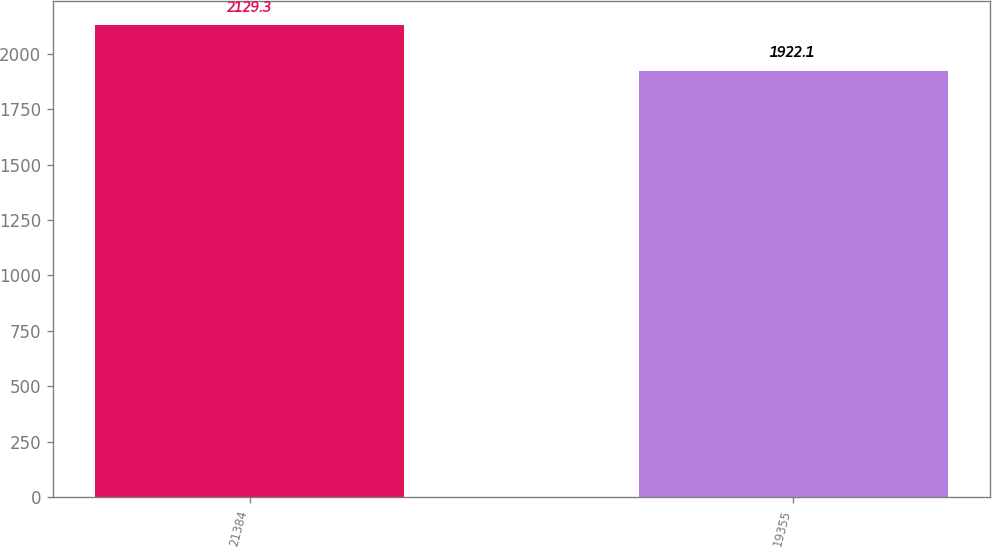<chart> <loc_0><loc_0><loc_500><loc_500><bar_chart><fcel>21384<fcel>19355<nl><fcel>2129.3<fcel>1922.1<nl></chart> 